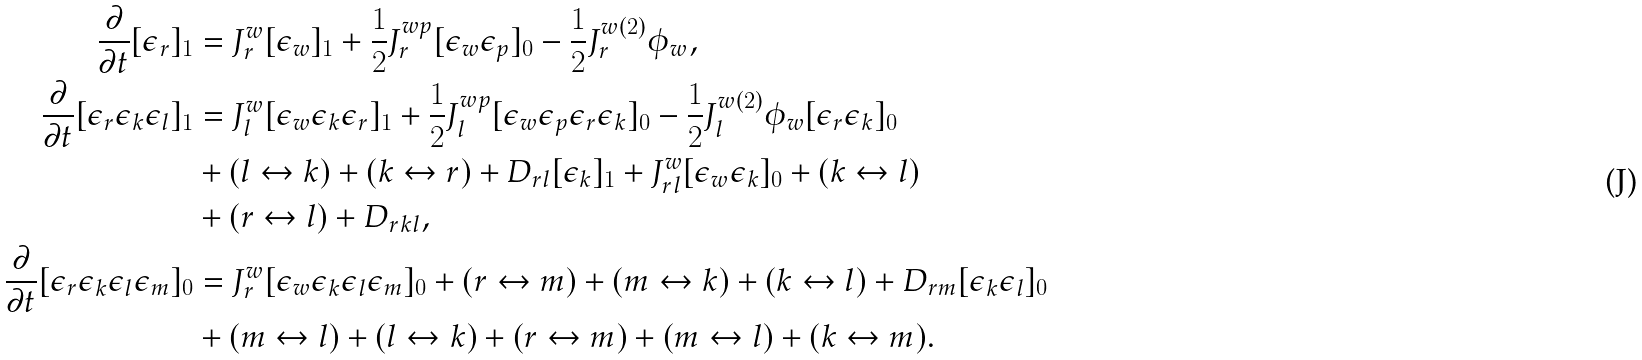Convert formula to latex. <formula><loc_0><loc_0><loc_500><loc_500>\frac { \partial } { \partial t } [ \epsilon _ { r } ] _ { 1 } & = J _ { r } ^ { w } [ \epsilon _ { w } ] _ { 1 } + \frac { 1 } { 2 } J _ { r } ^ { w p } [ \epsilon _ { w } \epsilon _ { p } ] _ { 0 } - \frac { 1 } { 2 } J _ { r } ^ { w ( 2 ) } \phi _ { w } , \\ \frac { \partial } { \partial t } [ \epsilon _ { r } \epsilon _ { k } \epsilon _ { l } ] _ { 1 } & = J _ { l } ^ { w } [ \epsilon _ { w } \epsilon _ { k } \epsilon _ { r } ] _ { 1 } + \frac { 1 } { 2 } J _ { l } ^ { w p } [ \epsilon _ { w } \epsilon _ { p } \epsilon _ { r } \epsilon _ { k } ] _ { 0 } - \frac { 1 } { 2 } J _ { l } ^ { w ( 2 ) } \phi _ { w } [ \epsilon _ { r } \epsilon _ { k } ] _ { 0 } \\ & + ( l \leftrightarrow k ) + ( k \leftrightarrow r ) + D _ { r l } [ \epsilon _ { k } ] _ { 1 } + J _ { r l } ^ { w } [ \epsilon _ { w } \epsilon _ { k } ] _ { 0 } + ( k \leftrightarrow l ) \\ & + ( r \leftrightarrow l ) + D _ { r k l } , \\ \frac { \partial } { \partial t } [ \epsilon _ { r } \epsilon _ { k } \epsilon _ { l } \epsilon _ { m } ] _ { 0 } & = J _ { r } ^ { w } [ \epsilon _ { w } \epsilon _ { k } \epsilon _ { l } \epsilon _ { m } ] _ { 0 } + ( r \leftrightarrow m ) + ( m \leftrightarrow k ) + ( k \leftrightarrow l ) + D _ { r m } [ \epsilon _ { k } \epsilon _ { l } ] _ { 0 } \\ & + ( m \leftrightarrow l ) + ( l \leftrightarrow k ) + ( r \leftrightarrow m ) + ( m \leftrightarrow l ) + ( k \leftrightarrow m ) .</formula> 